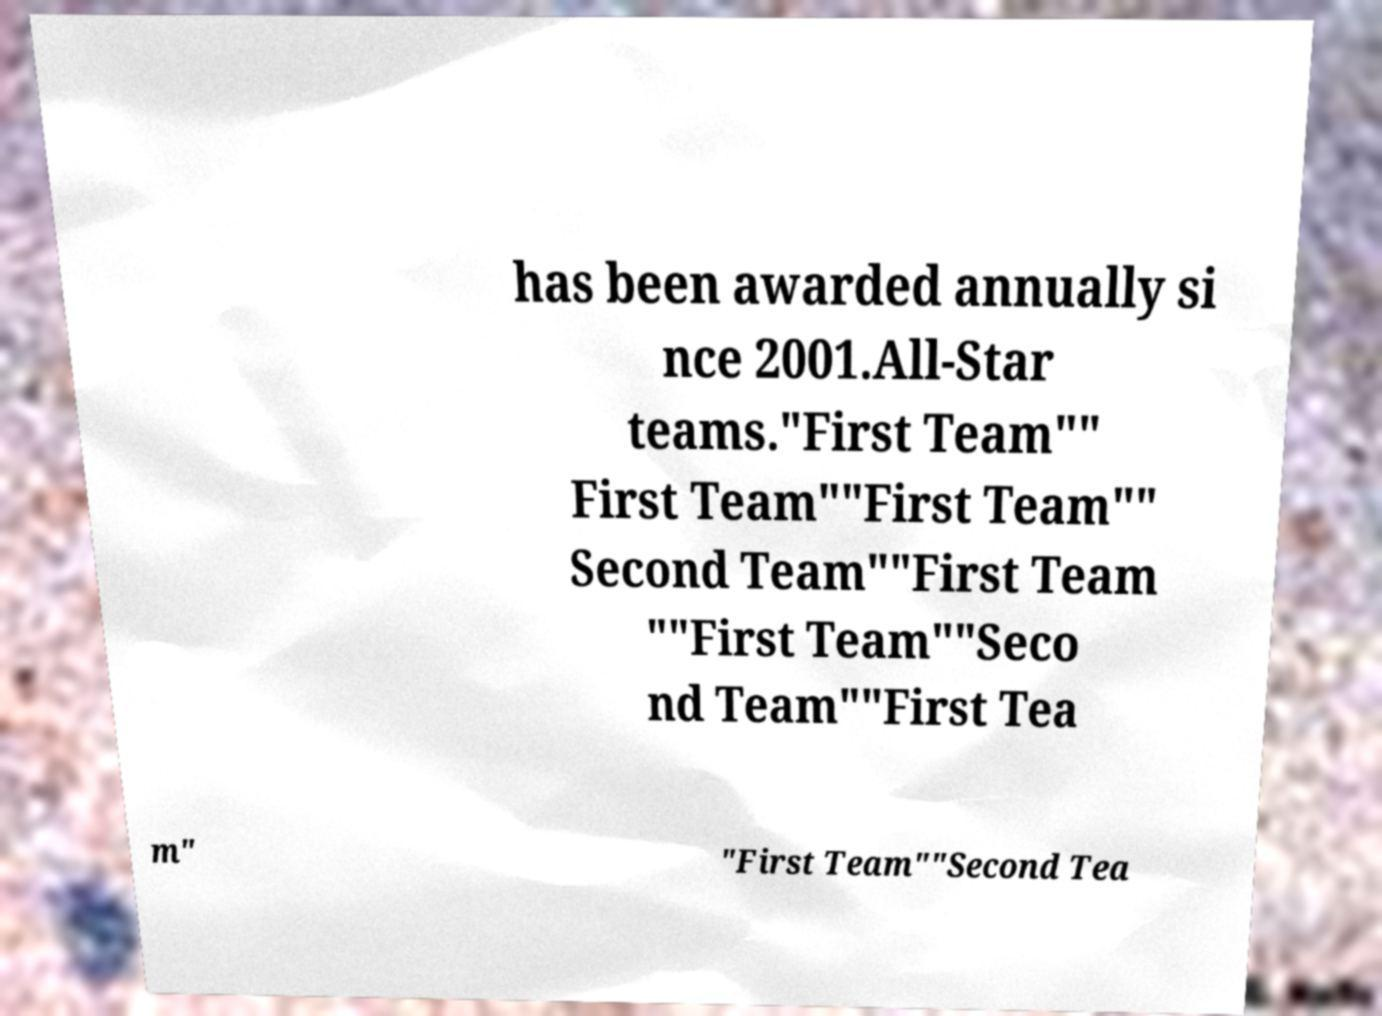What messages or text are displayed in this image? I need them in a readable, typed format. has been awarded annually si nce 2001.All-Star teams."First Team"" First Team""First Team"" Second Team""First Team ""First Team""Seco nd Team""First Tea m" "First Team""Second Tea 